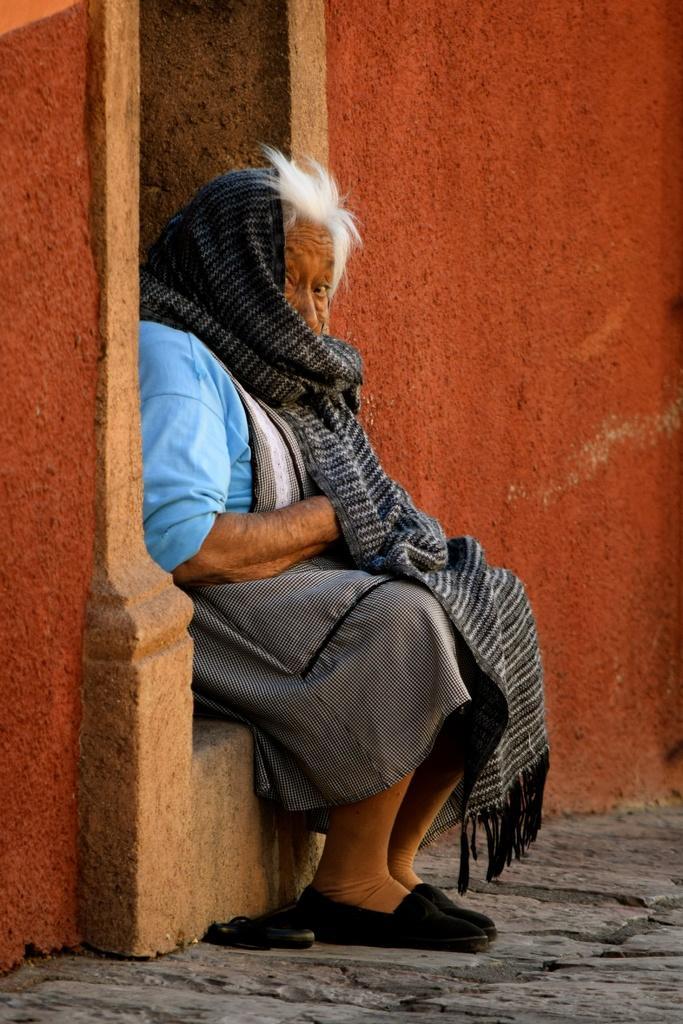In one or two sentences, can you explain what this image depicts? In this image, we can see a lady sitting. We can also see the wall and the ground with some objects. 